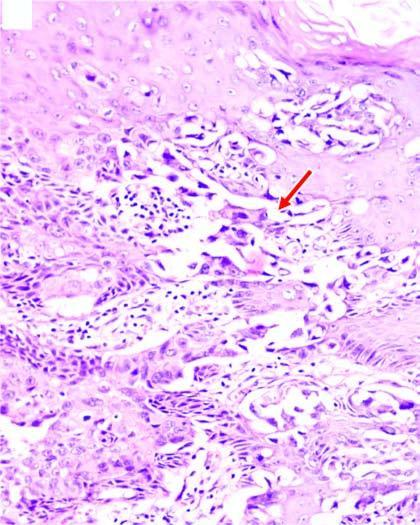s the sectioned surface of the lung clefts in the epidermal layers containing large tumour cells?
Answer the question using a single word or phrase. No 